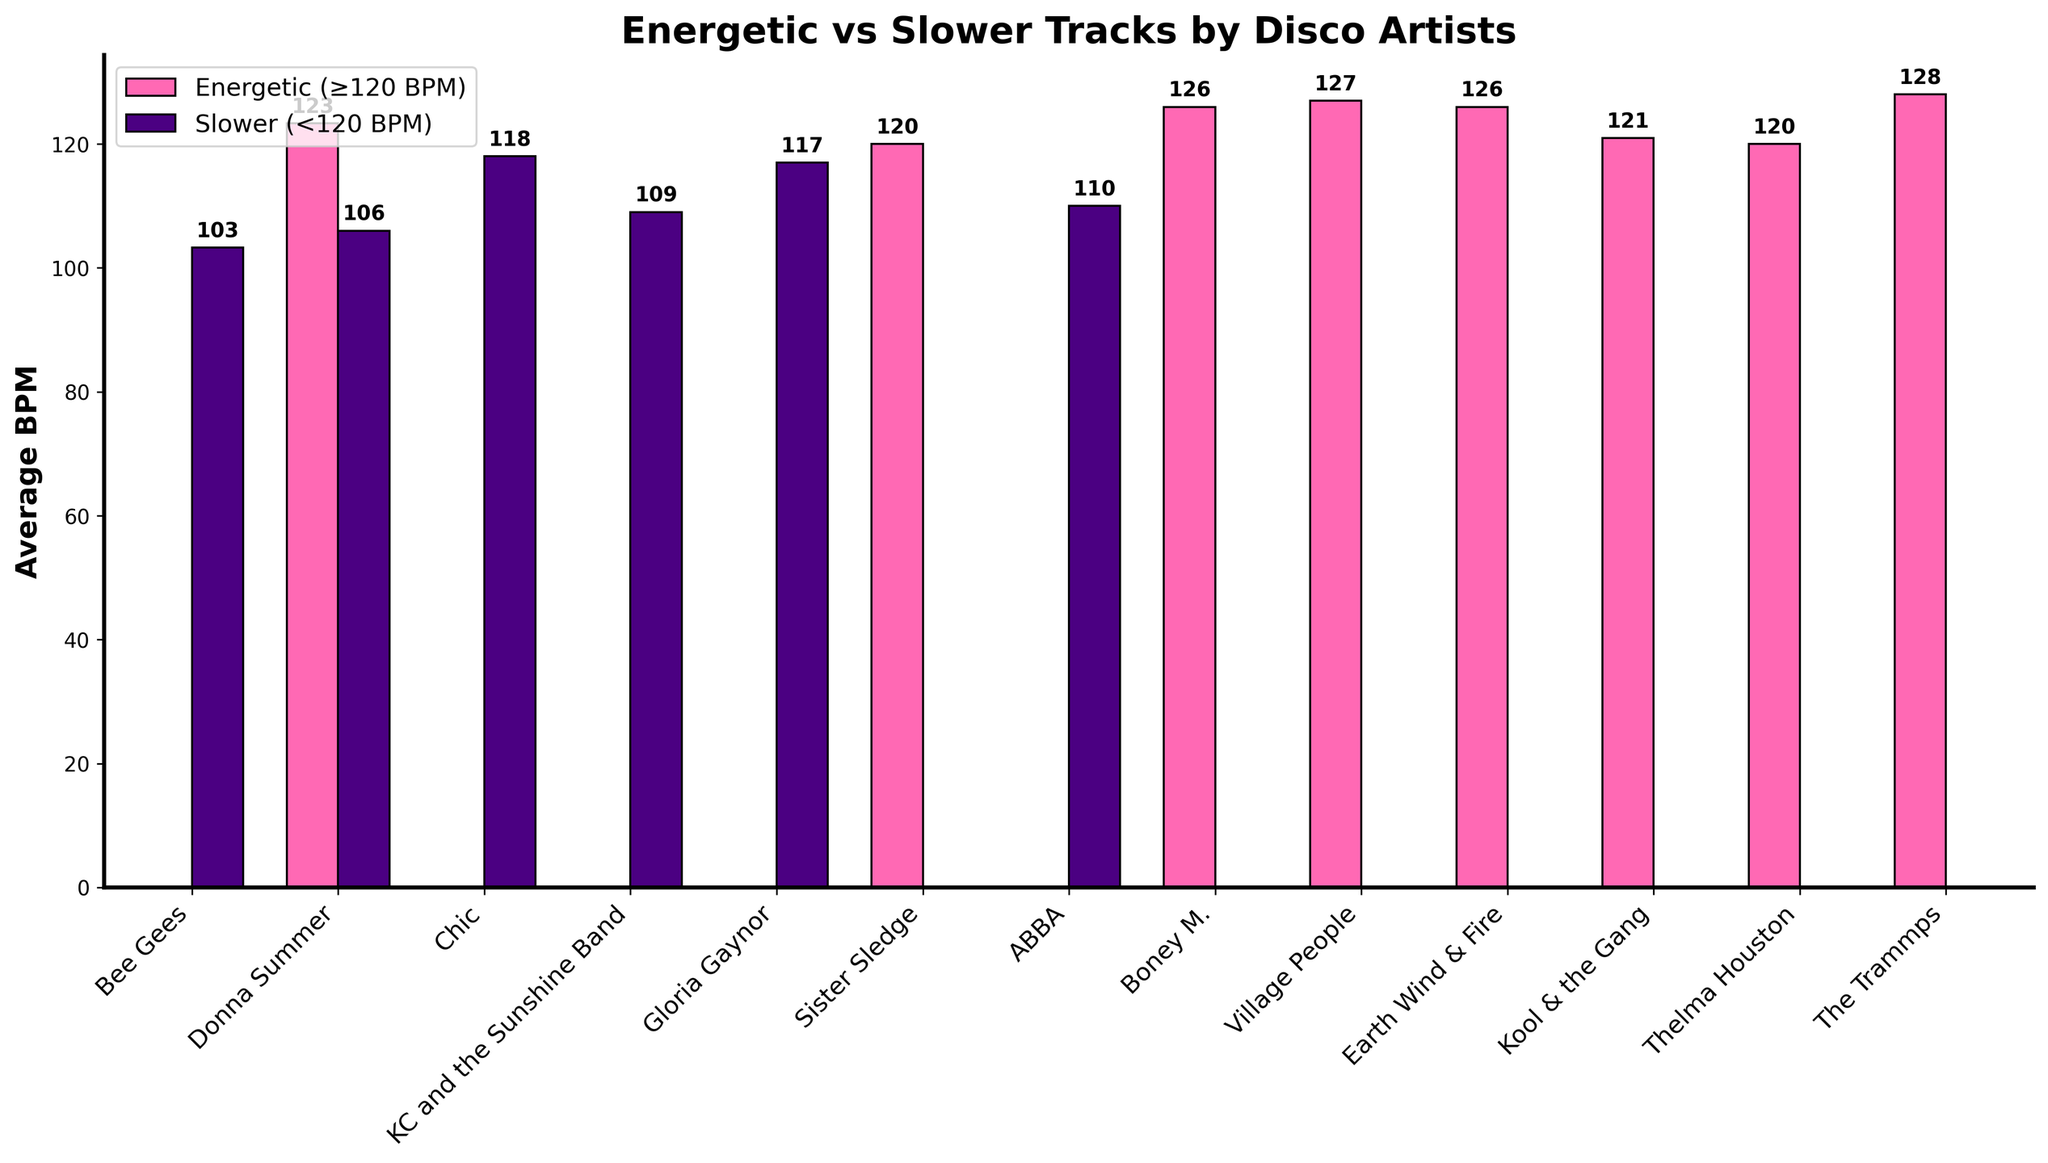Which artist has the highest average BPM for energetic tracks? Look at the height of the bars labeled 'Energetic (≥120 BPM)', and identify which artist's bar is the highest. The Trammps' bar is the tallest.
Answer: The Trammps Which artist has the lowest average BPM for slower tracks? Examine the height of the bars labeled 'Slower (<120 BPM)', and determine which artist's bar is the shortest. The Bee Gees' bar is the shortest.
Answer: Bee Gees What's the difference in average BPM for energetic and slower tracks for Donna Summer? Subtract the average BPM of Donna Summer's slower tracks from her energetic tracks. The height of the energetic bar is 123 BPM, and for the slower tracks, it's 113 BPM.
Answer: 10 BPM Which artist has a greater difference in average BPM between energetic and slower tracks, Bee Gees or Earth Wind & Fire? Calculate the difference for both artists. For the Bee Gees, it's 103-94=9 BPM. For Earth Wind & Fire, it's 126-126=0 BPM. The Bee Gees have a greater difference.
Answer: Bee Gees What is the average BPM for slower tracks across all artists? Add the heights of all bars labeled 'Slower (<120 BPM)' and divide by the number of artists. The bars are at 94 (Bee Gees), 113 (Donna Summer), 119 (Chic), 117 (KC and the Sunshine Band), 117 (Gloria Gaynor), 113 (Sister Sledge), 110 (ABBA), 103 (Boney M.), 109 (Village People), 109 (Earth Wind and Fire), 119 (Kool & the Gang), and 113 (Thelma Houston). Total = 1136 BPM, Artists = 12, Average = 1136/12
Answer: 113 BPM How do the average BPMs for energetic tracks of Donna Summer and Gloria Gaynor compare? Compare the heights of the bars labeled 'Energetic (≥120 BPM)' for both. Donna Summer's bar is slightly taller than Gloria Gaynor's.
Answer: Donna Summer's is higher Which artists have the same average BPM for both energetic and slower tracks? Look for artists whose bars for 'Energetic (≥120 BPM)' and 'Slower (<120 BPM)' are at the same height. Earth Wind & Fire is the only one with the same height for both bars (126 BPM).
Answer: Earth Wind & Fire What is the total average BPM for all energetic tracks across all artists? Add the heights of all bars labeled 'Energetic (≥120 BPM)' and divide by the number of artists. The bars are at 126 (Donna Summer), 119 (Chic), 110 (KC and the Sunshine Band), 113 (Gloria Gaynor), 120 (Sister Sledge), 121 (Kool & the Gang), 113 (Thelma Houston), 128 (The Trammps). Total = 850 BPM, Artists = 8, Average = 850/8
Answer: 106 BPM 